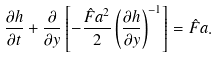<formula> <loc_0><loc_0><loc_500><loc_500>\frac { \partial h } { \partial t } + \frac { \partial } { \partial y } \left [ - \frac { \hat { F } a ^ { 2 } } { 2 } \left ( \frac { \partial h } { \partial y } \right ) ^ { - 1 } \right ] = \hat { F } a .</formula> 